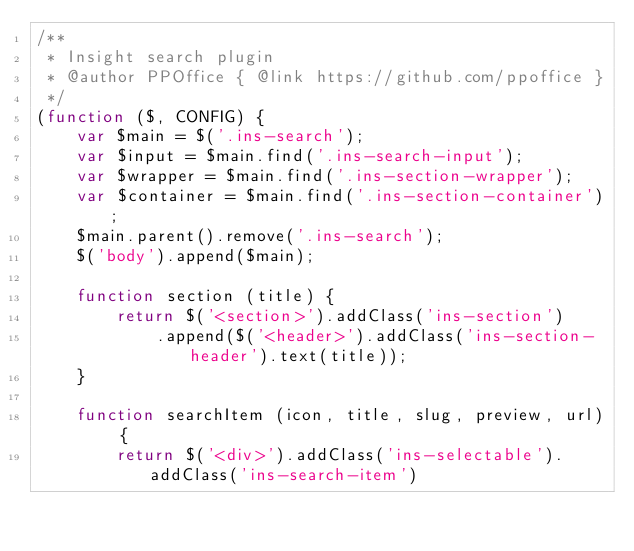Convert code to text. <code><loc_0><loc_0><loc_500><loc_500><_JavaScript_>/**
 * Insight search plugin
 * @author PPOffice { @link https://github.com/ppoffice }
 */
(function ($, CONFIG) {
    var $main = $('.ins-search');
    var $input = $main.find('.ins-search-input');
    var $wrapper = $main.find('.ins-section-wrapper');
    var $container = $main.find('.ins-section-container');
    $main.parent().remove('.ins-search');
    $('body').append($main);

    function section (title) {
        return $('<section>').addClass('ins-section')
            .append($('<header>').addClass('ins-section-header').text(title));
    }

    function searchItem (icon, title, slug, preview, url) {
        return $('<div>').addClass('ins-selectable').addClass('ins-search-item')</code> 